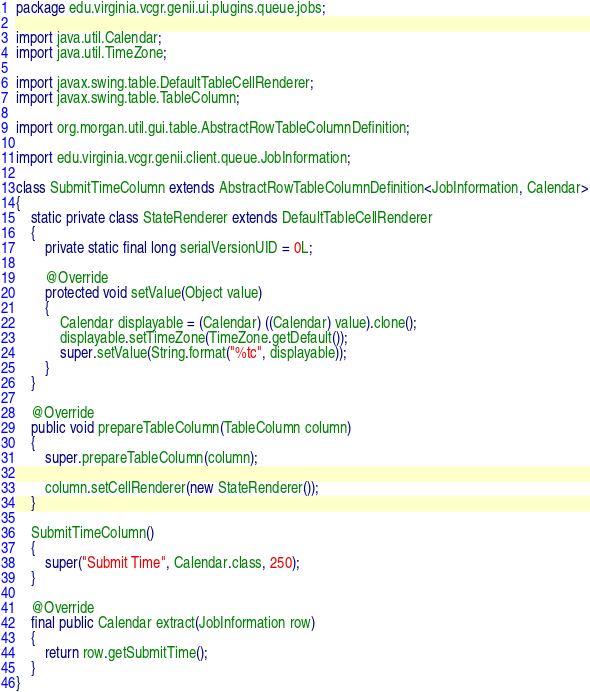<code> <loc_0><loc_0><loc_500><loc_500><_Java_>package edu.virginia.vcgr.genii.ui.plugins.queue.jobs;

import java.util.Calendar;
import java.util.TimeZone;

import javax.swing.table.DefaultTableCellRenderer;
import javax.swing.table.TableColumn;

import org.morgan.util.gui.table.AbstractRowTableColumnDefinition;

import edu.virginia.vcgr.genii.client.queue.JobInformation;

class SubmitTimeColumn extends AbstractRowTableColumnDefinition<JobInformation, Calendar>
{
	static private class StateRenderer extends DefaultTableCellRenderer
	{
		private static final long serialVersionUID = 0L;

		@Override
		protected void setValue(Object value)
		{
			Calendar displayable = (Calendar) ((Calendar) value).clone();
			displayable.setTimeZone(TimeZone.getDefault());
			super.setValue(String.format("%tc", displayable));
		}
	}

	@Override
	public void prepareTableColumn(TableColumn column)
	{
		super.prepareTableColumn(column);

		column.setCellRenderer(new StateRenderer());
	}

	SubmitTimeColumn()
	{
		super("Submit Time", Calendar.class, 250);
	}

	@Override
	final public Calendar extract(JobInformation row)
	{
		return row.getSubmitTime();
	}
}</code> 